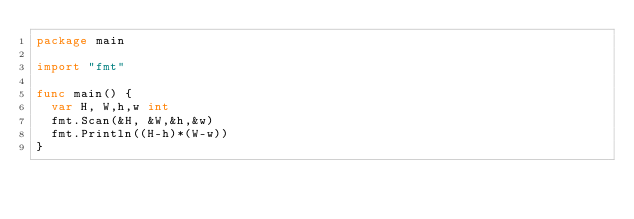Convert code to text. <code><loc_0><loc_0><loc_500><loc_500><_Go_>package main

import "fmt"

func main() {
	var H, W,h,w int
	fmt.Scan(&H, &W,&h,&w)
	fmt.Println((H-h)*(W-w))
}
</code> 